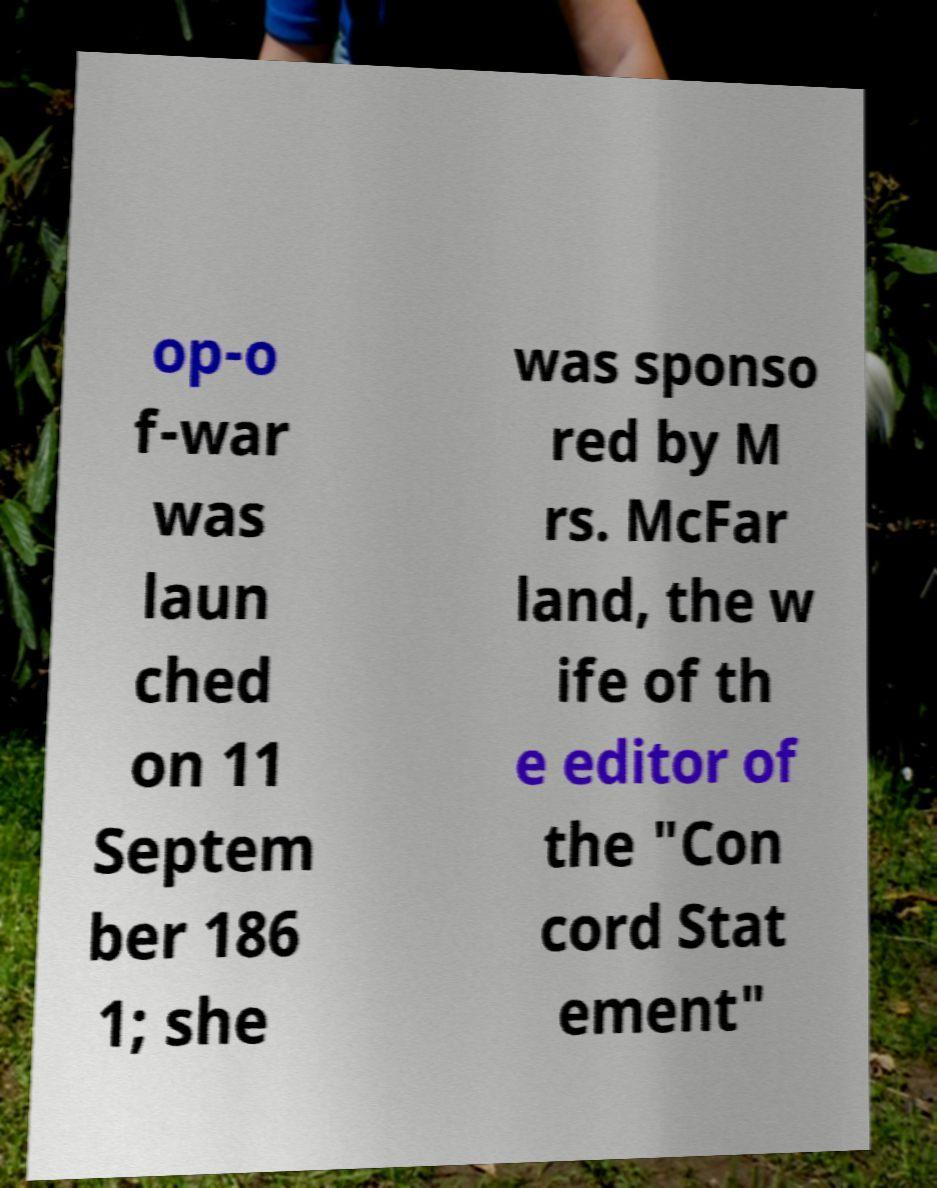Please identify and transcribe the text found in this image. op-o f-war was laun ched on 11 Septem ber 186 1; she was sponso red by M rs. McFar land, the w ife of th e editor of the "Con cord Stat ement" 